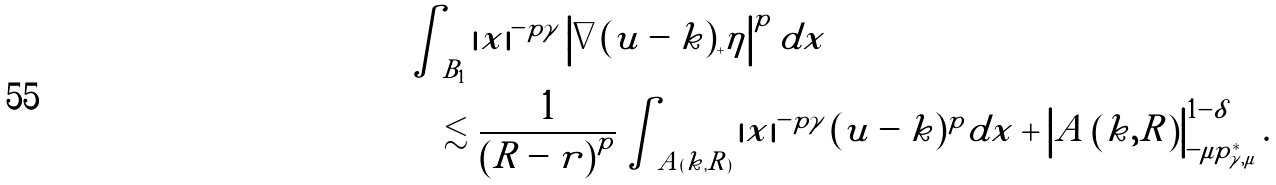<formula> <loc_0><loc_0><loc_500><loc_500>& \int _ { B _ { 1 } } \left | x \right | ^ { - p \gamma } \left | \nabla ( u - k ) _ { + } \eta \right | ^ { p } d x \\ & \quad \lesssim \frac { 1 } { \left ( R - r \right ) ^ { p } } \int _ { A ( k , R ) } \left | x \right | ^ { - p \gamma } ( u - k ) ^ { p } d x + \left | A \left ( k , R \right ) \right | _ { - \mu p _ { \gamma , \mu } ^ { * } } ^ { 1 - \delta } .</formula> 